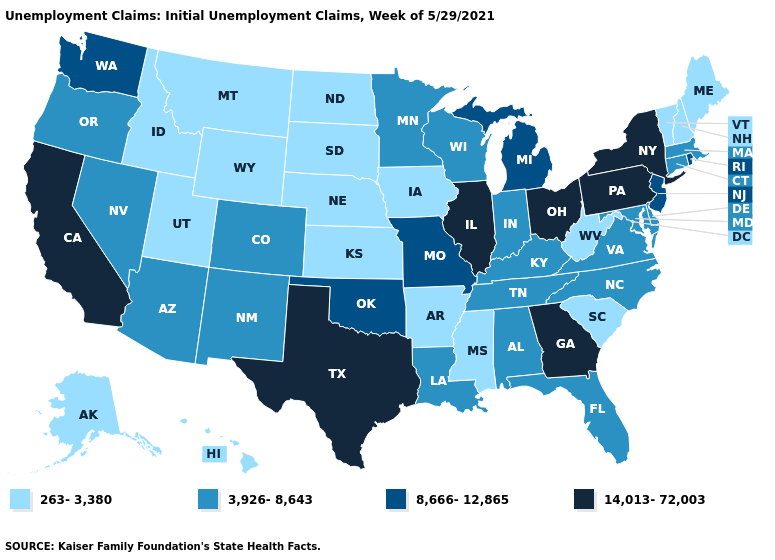Among the states that border Indiana , does Michigan have the highest value?
Be succinct. No. Which states have the lowest value in the USA?
Quick response, please. Alaska, Arkansas, Hawaii, Idaho, Iowa, Kansas, Maine, Mississippi, Montana, Nebraska, New Hampshire, North Dakota, South Carolina, South Dakota, Utah, Vermont, West Virginia, Wyoming. Name the states that have a value in the range 8,666-12,865?
Quick response, please. Michigan, Missouri, New Jersey, Oklahoma, Rhode Island, Washington. Does Texas have the lowest value in the USA?
Answer briefly. No. Does the first symbol in the legend represent the smallest category?
Write a very short answer. Yes. Is the legend a continuous bar?
Be succinct. No. Name the states that have a value in the range 14,013-72,003?
Be succinct. California, Georgia, Illinois, New York, Ohio, Pennsylvania, Texas. What is the value of Hawaii?
Concise answer only. 263-3,380. What is the value of Wyoming?
Quick response, please. 263-3,380. Does Alabama have the same value as North Carolina?
Keep it brief. Yes. Does Oklahoma have the same value as Missouri?
Write a very short answer. Yes. What is the lowest value in the South?
Answer briefly. 263-3,380. What is the highest value in states that border Wyoming?
Give a very brief answer. 3,926-8,643. Among the states that border Nebraska , which have the lowest value?
Answer briefly. Iowa, Kansas, South Dakota, Wyoming. Name the states that have a value in the range 3,926-8,643?
Answer briefly. Alabama, Arizona, Colorado, Connecticut, Delaware, Florida, Indiana, Kentucky, Louisiana, Maryland, Massachusetts, Minnesota, Nevada, New Mexico, North Carolina, Oregon, Tennessee, Virginia, Wisconsin. 